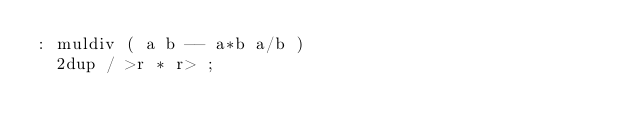Convert code to text. <code><loc_0><loc_0><loc_500><loc_500><_Forth_>: muldiv ( a b -- a*b a/b )
  2dup / >r * r> ;
</code> 